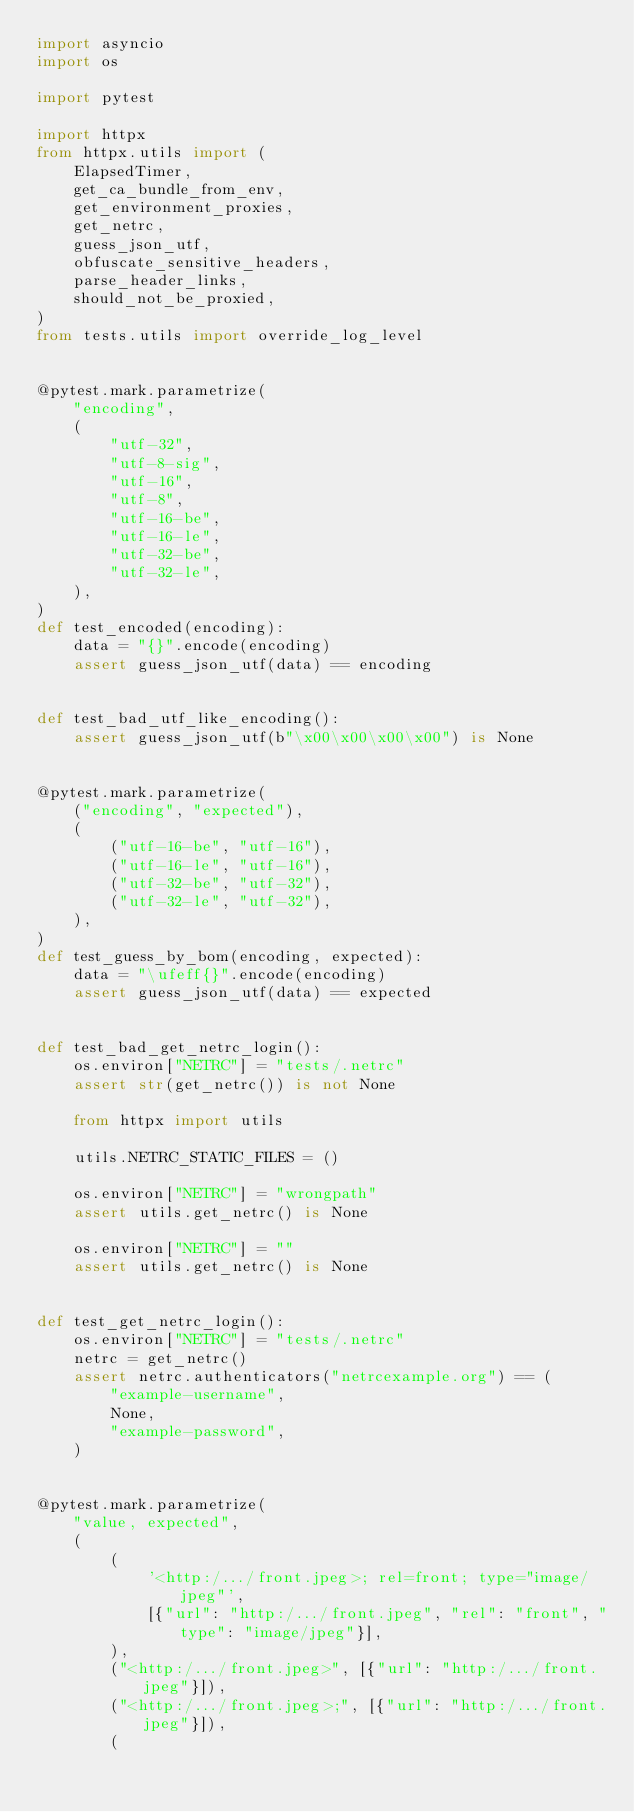<code> <loc_0><loc_0><loc_500><loc_500><_Python_>import asyncio
import os

import pytest

import httpx
from httpx.utils import (
    ElapsedTimer,
    get_ca_bundle_from_env,
    get_environment_proxies,
    get_netrc,
    guess_json_utf,
    obfuscate_sensitive_headers,
    parse_header_links,
    should_not_be_proxied,
)
from tests.utils import override_log_level


@pytest.mark.parametrize(
    "encoding",
    (
        "utf-32",
        "utf-8-sig",
        "utf-16",
        "utf-8",
        "utf-16-be",
        "utf-16-le",
        "utf-32-be",
        "utf-32-le",
    ),
)
def test_encoded(encoding):
    data = "{}".encode(encoding)
    assert guess_json_utf(data) == encoding


def test_bad_utf_like_encoding():
    assert guess_json_utf(b"\x00\x00\x00\x00") is None


@pytest.mark.parametrize(
    ("encoding", "expected"),
    (
        ("utf-16-be", "utf-16"),
        ("utf-16-le", "utf-16"),
        ("utf-32-be", "utf-32"),
        ("utf-32-le", "utf-32"),
    ),
)
def test_guess_by_bom(encoding, expected):
    data = "\ufeff{}".encode(encoding)
    assert guess_json_utf(data) == expected


def test_bad_get_netrc_login():
    os.environ["NETRC"] = "tests/.netrc"
    assert str(get_netrc()) is not None

    from httpx import utils

    utils.NETRC_STATIC_FILES = ()

    os.environ["NETRC"] = "wrongpath"
    assert utils.get_netrc() is None

    os.environ["NETRC"] = ""
    assert utils.get_netrc() is None


def test_get_netrc_login():
    os.environ["NETRC"] = "tests/.netrc"
    netrc = get_netrc()
    assert netrc.authenticators("netrcexample.org") == (
        "example-username",
        None,
        "example-password",
    )


@pytest.mark.parametrize(
    "value, expected",
    (
        (
            '<http:/.../front.jpeg>; rel=front; type="image/jpeg"',
            [{"url": "http:/.../front.jpeg", "rel": "front", "type": "image/jpeg"}],
        ),
        ("<http:/.../front.jpeg>", [{"url": "http:/.../front.jpeg"}]),
        ("<http:/.../front.jpeg>;", [{"url": "http:/.../front.jpeg"}]),
        (</code> 